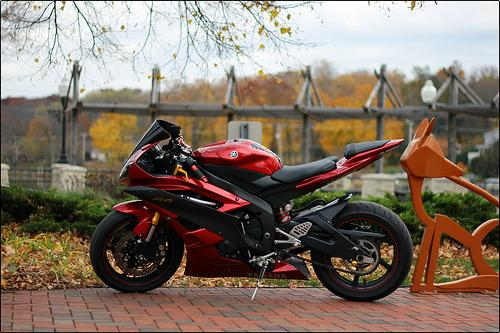Describe the condition of the trees in the image. The trees have fall colors with yellow and orange leaves, and appear sparsely leaved as they are losing their leaves. What is the main color of the statue next to the motorbike? The main color of the statue next to the motorbike is orange. What kind of bushes are in the background and what is their color? There is a row of green bushes in the background of the image. Count the number of wheels visible in the image and describe their characteristics. There are two wheels visible in the image, one front tire and one rear tire of a motorbike, both made of black rubber. What is the main mode of transportation in the image? A red and black motorbike is the main mode of transportation in the image. Give a brief description of the image's setting. The image features a brick paved ground with green bushes and trees with fall colors, and a metal structure surrounded by grill iron fencing. Identify the most unusual object in the image and describe it. There is an orange fox-shaped statue next to the motorbike in the image. Describe the ground composition and mention any noteworthy items on it. The ground is composed of red and gray brick pavement, with fallen leaves scattered on it. Which object is at coordinates X:330 Y:207 with Width:50 Height:50? rear tire of motorbike What is the sentiment of an image with a red and black motorbike parked beside an orange horse-shaped statue? neutral Explain the composition of the object at X:81 Y:260 Width:35 Height:35. tire made of rubber Do the trees in the background have purple leaves? The image mentions "yellow and orange leaves on trees" and "trees with fall colors in the background" but there is no mention of purple leaves. This instruction is misleading because it assumes that the trees have purple leaves. Which choice best describes the object at X:336 Y:243 Width:41 Height:41: 1) chain of the bike 2) bush 3) car tire 4) fence 1) chain of the bike Is there an anomaly with a street sign in the image? no Is there a blue street sign attached to the metal light pole? The image mentions a "back of street sign" and "metal light pole" but there is no mention of the street sign being blue. This instruction is misleading because it assumes that the street sign is blue. Describe the material the ground is made of. red bricks Which object is at X:90 Y:216 Width:79 Height:79, and what does it belong to? front tire of motorbike Name the object found at X:403 Y:128 with Width:91 Height:91. orange fox looking object What type of path is made of bricks? stone path Describe the quality of an image that shows a motorbike, a statue, and a red brick pavement. good Is there a green motorcycle parked near the statue? The image mentions a "red and black motorbike" but not a green one. This instruction is misleading because it assumes that there is a green motorcycle in the image. What are the colors and shapes of the trees in the background? red and yellow, fall colors Is the sky filled with blue clouds? The image mentions "clouds in the sky" but there is no mention of them being blue. This instruction is misleading because it assumes that the clouds are blue. How would you describe the interaction between a wooden deer figurine and a red and black motorbike? non-interactive What is the color of the object at X:369 Y:24 Width:66 Height:66? clouds Are the bricks on the ground made of gold? The image mentions "red and gray brick pavement" and "ground made of red bricks" but there is no mention of gold bricks. This instruction is misleading because it assumes that the bricks on the ground are made of gold. What is the nature of a green object with coordinates X:445 Y:199 Width:31 Height:31? leaves on the bush Locate and describe the windshield of the bike in the image. X:139 Y:119 Width:31 Height:31 Identify the object at X:419 Y:144 Width:24 Height:24 and describe its color. orange paint on sculpture Correct the OCR reading: "this is a peddal" this is a pedal Can you see a wooden fox sculpture next to the bike? The image mentions a "wooden deer figurine" but not a wooden fox sculpture. This instruction is misleading because it assumes that there is a wooden fox sculpture in the image. What position and size is the metallic light pole in the image? X:47 Y:66 Width:35 Height:35 